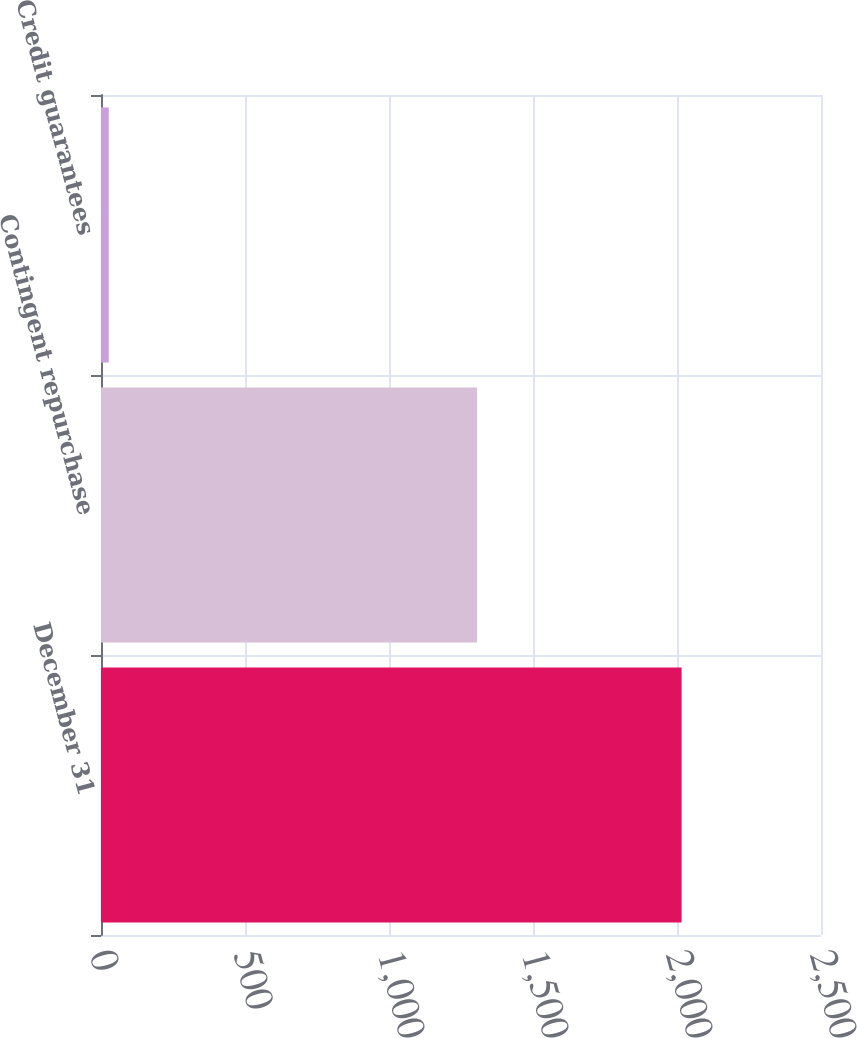Convert chart to OTSL. <chart><loc_0><loc_0><loc_500><loc_500><bar_chart><fcel>December 31<fcel>Contingent repurchase<fcel>Credit guarantees<nl><fcel>2016<fcel>1306<fcel>27<nl></chart> 